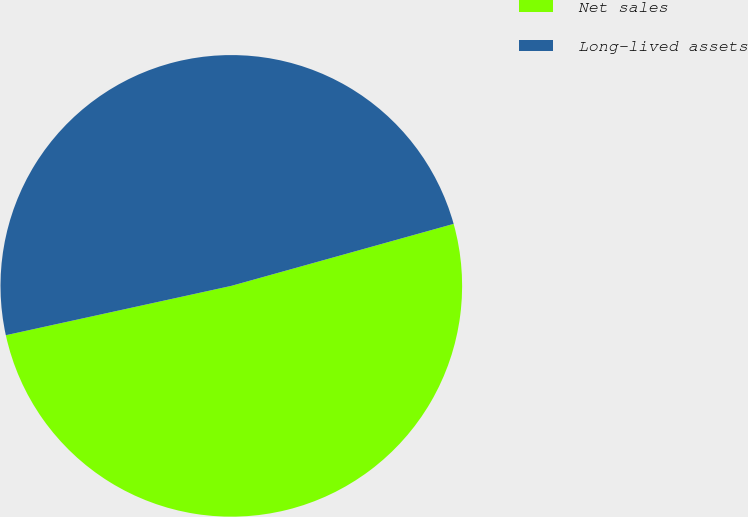<chart> <loc_0><loc_0><loc_500><loc_500><pie_chart><fcel>Net sales<fcel>Long-lived assets<nl><fcel>50.9%<fcel>49.1%<nl></chart> 